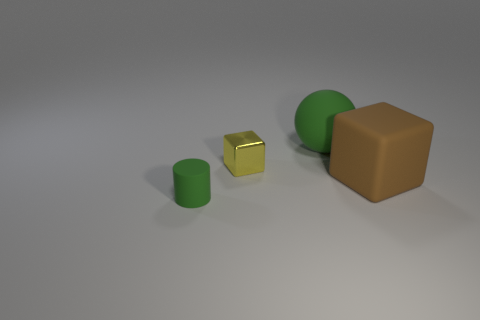Is the number of small blocks that are behind the yellow cube the same as the number of large cylinders?
Your response must be concise. Yes. There is a big object that is behind the tiny cube; are there any rubber cylinders that are right of it?
Provide a short and direct response. No. Is there anything else of the same color as the matte block?
Ensure brevity in your answer.  No. Is the material of the big thing right of the matte sphere the same as the large green thing?
Your response must be concise. Yes. Are there an equal number of brown rubber things to the left of the yellow thing and brown cubes to the left of the tiny green cylinder?
Keep it short and to the point. Yes. There is a green matte thing that is behind the small thing that is right of the small matte cylinder; what is its size?
Your answer should be compact. Large. The object that is left of the sphere and behind the tiny green rubber cylinder is made of what material?
Give a very brief answer. Metal. How many other objects are the same size as the green rubber cylinder?
Ensure brevity in your answer.  1. The small rubber thing is what color?
Provide a succinct answer. Green. Does the rubber thing that is on the right side of the green ball have the same color as the rubber thing that is on the left side of the yellow object?
Your response must be concise. No. 